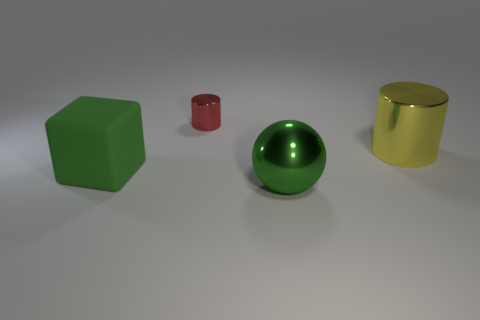Are there any other things that have the same size as the red shiny thing?
Offer a terse response. No. How many big objects are brown metal blocks or cubes?
Provide a succinct answer. 1. Is there a thing of the same color as the big rubber block?
Your response must be concise. Yes. What shape is the green matte object that is the same size as the yellow cylinder?
Your response must be concise. Cube. Is the color of the large thing left of the large green metallic thing the same as the shiny ball?
Provide a short and direct response. Yes. What number of objects are metal things behind the green rubber thing or green matte things?
Your response must be concise. 3. Are there more green rubber things behind the big green shiny thing than rubber things left of the cube?
Provide a succinct answer. Yes. Is the ball made of the same material as the large yellow object?
Your answer should be compact. Yes. There is a object that is in front of the tiny cylinder and on the left side of the big ball; what shape is it?
Give a very brief answer. Cube. The big yellow thing that is the same material as the large sphere is what shape?
Your answer should be compact. Cylinder. 